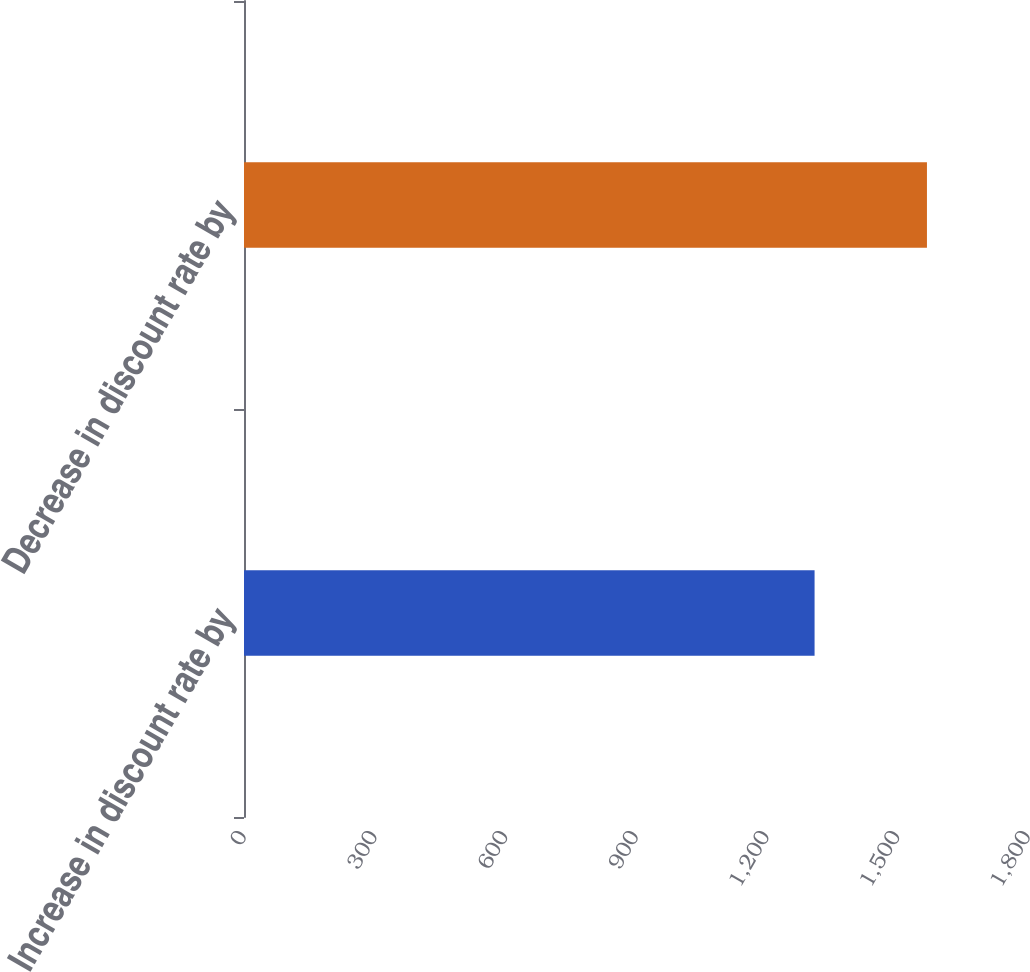<chart> <loc_0><loc_0><loc_500><loc_500><bar_chart><fcel>Increase in discount rate by<fcel>Decrease in discount rate by<nl><fcel>1310<fcel>1568<nl></chart> 